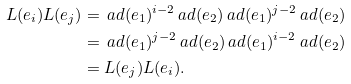<formula> <loc_0><loc_0><loc_500><loc_500>L ( e _ { i } ) L ( e _ { j } ) & = \ a d ( e _ { 1 } ) ^ { i - 2 } \ a d ( e _ { 2 } ) \ a d ( e _ { 1 } ) ^ { j - 2 } \ a d ( e _ { 2 } ) \\ & = \ a d ( e _ { 1 } ) ^ { j - 2 } \ a d ( e _ { 2 } ) \ a d ( e _ { 1 } ) ^ { i - 2 } \ a d ( e _ { 2 } ) \\ & = L ( e _ { j } ) L ( e _ { i } ) .</formula> 